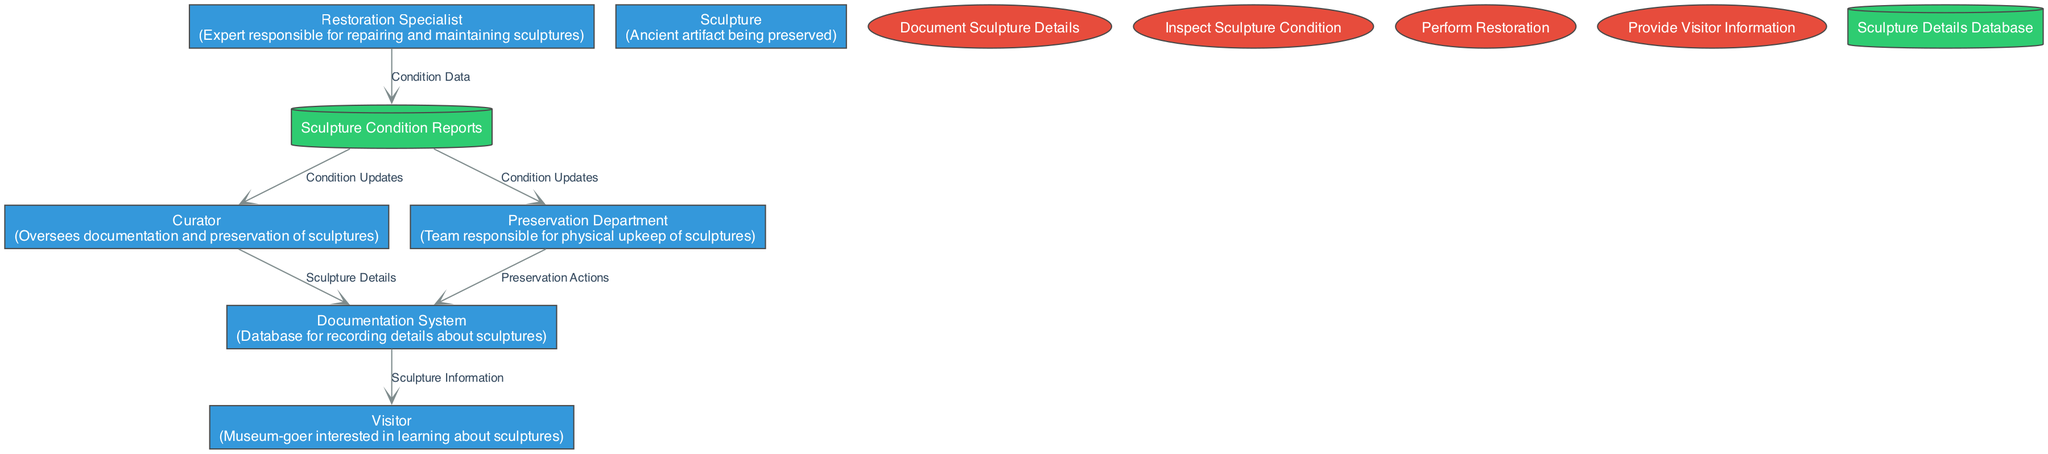What is the role of the Curator? The Curator oversees the documentation and preservation of sculptures, as indicated in the entities section of the diagram.
Answer: Oversees documentation and preservation of sculptures How many data stores are there? In the diagram, there are two data stores: Sculpture Condition Reports and Sculpture Details Database.
Answer: 2 What type of information does the Preservation Department provide to the Documentation System? The Preservation Department provides preservation actions as indicated by the data flow coming from it to the Documentation System.
Answer: Preservation Actions Who is responsible for performing restorations? The Restoration Specialist is identified as the expert responsible for repairing and maintaining sculptures according to the entity's role in the diagram.
Answer: Restoration Specialist What data flows from the Documentation System to Visitors? The data that flows from the Documentation System to Visitors is Sculpture Information, as shown in the data flows section.
Answer: Sculpture Information How does the Curator receive condition updates? The Curator receives condition updates from the Sculpture Condition Reports data store, indicated by the direct data flow from the reports to the curator in the diagram.
Answer: Condition Updates Which department is responsible for inspecting sculpture condition? The diagram identifies the Preservation Department as responsible for inspecting the physical condition of the sculptures through regular checks on sculpture conditions.
Answer: Preservation Department What process captures detailed information about sculptures? The process that captures detailed information about sculptures is called Document Sculpture Details, explicitly stated in the processes section of the diagram.
Answer: Document Sculpture Details What color represents data stores in the diagram? Data stores are represented in green, indicating the fill color assigned to those nodes in the diagram structure.
Answer: Green 